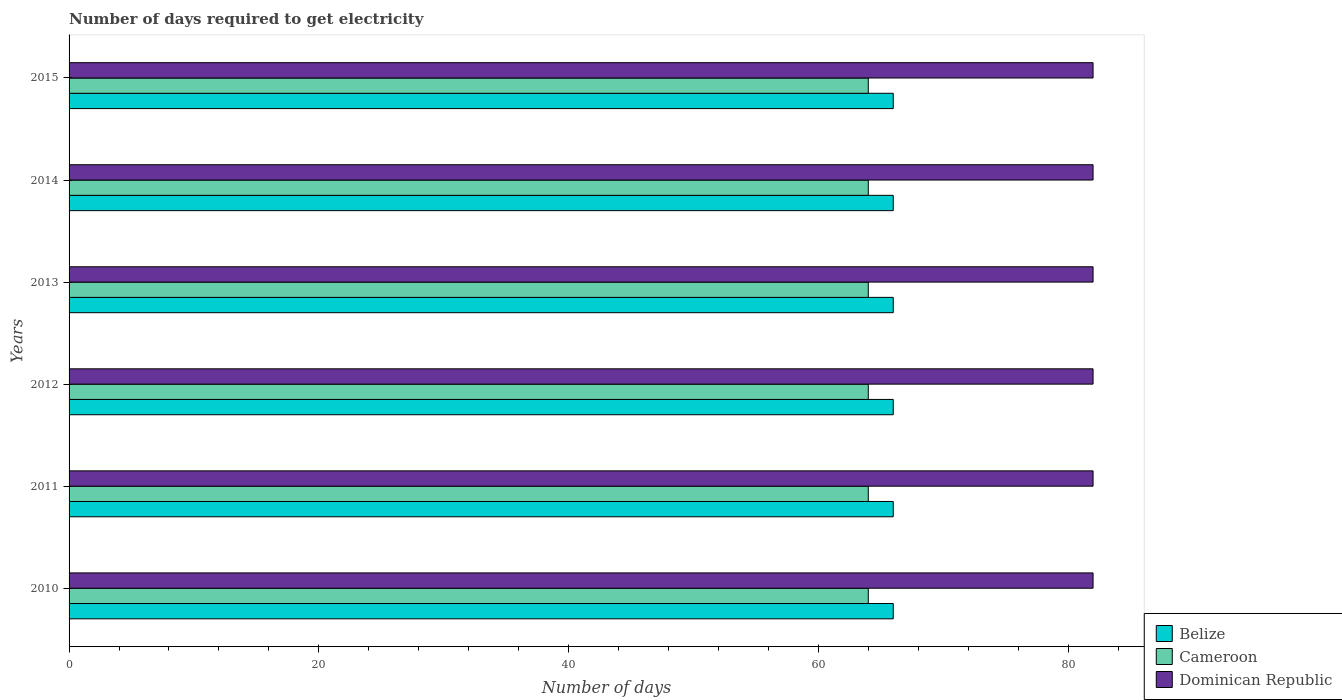How many groups of bars are there?
Make the answer very short. 6. Are the number of bars on each tick of the Y-axis equal?
Make the answer very short. Yes. How many bars are there on the 4th tick from the top?
Provide a short and direct response. 3. How many bars are there on the 3rd tick from the bottom?
Offer a terse response. 3. What is the label of the 2nd group of bars from the top?
Offer a very short reply. 2014. What is the number of days required to get electricity in in Cameroon in 2012?
Give a very brief answer. 64. Across all years, what is the maximum number of days required to get electricity in in Cameroon?
Offer a terse response. 64. Across all years, what is the minimum number of days required to get electricity in in Belize?
Make the answer very short. 66. In which year was the number of days required to get electricity in in Cameroon maximum?
Your answer should be very brief. 2010. What is the total number of days required to get electricity in in Cameroon in the graph?
Your answer should be very brief. 384. What is the difference between the number of days required to get electricity in in Cameroon in 2012 and that in 2013?
Ensure brevity in your answer.  0. What is the difference between the number of days required to get electricity in in Dominican Republic in 2011 and the number of days required to get electricity in in Cameroon in 2012?
Offer a terse response. 18. In the year 2013, what is the difference between the number of days required to get electricity in in Dominican Republic and number of days required to get electricity in in Cameroon?
Make the answer very short. 18. In how many years, is the number of days required to get electricity in in Dominican Republic greater than 64 days?
Offer a very short reply. 6. Is the number of days required to get electricity in in Dominican Republic in 2012 less than that in 2015?
Your answer should be very brief. No. What is the difference between the highest and the second highest number of days required to get electricity in in Cameroon?
Make the answer very short. 0. What is the difference between the highest and the lowest number of days required to get electricity in in Belize?
Keep it short and to the point. 0. In how many years, is the number of days required to get electricity in in Belize greater than the average number of days required to get electricity in in Belize taken over all years?
Keep it short and to the point. 0. What does the 3rd bar from the top in 2014 represents?
Make the answer very short. Belize. What does the 2nd bar from the bottom in 2014 represents?
Offer a very short reply. Cameroon. Are all the bars in the graph horizontal?
Your answer should be very brief. Yes. How many years are there in the graph?
Give a very brief answer. 6. What is the difference between two consecutive major ticks on the X-axis?
Keep it short and to the point. 20. How many legend labels are there?
Offer a very short reply. 3. How are the legend labels stacked?
Provide a short and direct response. Vertical. What is the title of the graph?
Make the answer very short. Number of days required to get electricity. What is the label or title of the X-axis?
Give a very brief answer. Number of days. What is the Number of days of Cameroon in 2010?
Your answer should be compact. 64. What is the Number of days of Dominican Republic in 2011?
Make the answer very short. 82. What is the Number of days in Cameroon in 2013?
Offer a terse response. 64. What is the Number of days in Cameroon in 2014?
Keep it short and to the point. 64. What is the Number of days in Cameroon in 2015?
Ensure brevity in your answer.  64. Across all years, what is the maximum Number of days of Belize?
Ensure brevity in your answer.  66. What is the total Number of days in Belize in the graph?
Give a very brief answer. 396. What is the total Number of days in Cameroon in the graph?
Offer a very short reply. 384. What is the total Number of days of Dominican Republic in the graph?
Provide a short and direct response. 492. What is the difference between the Number of days in Dominican Republic in 2010 and that in 2011?
Provide a succinct answer. 0. What is the difference between the Number of days of Cameroon in 2010 and that in 2014?
Provide a short and direct response. 0. What is the difference between the Number of days in Dominican Republic in 2010 and that in 2014?
Offer a very short reply. 0. What is the difference between the Number of days in Belize in 2010 and that in 2015?
Give a very brief answer. 0. What is the difference between the Number of days of Cameroon in 2010 and that in 2015?
Provide a short and direct response. 0. What is the difference between the Number of days in Dominican Republic in 2010 and that in 2015?
Make the answer very short. 0. What is the difference between the Number of days in Belize in 2011 and that in 2012?
Your response must be concise. 0. What is the difference between the Number of days of Dominican Republic in 2011 and that in 2012?
Your answer should be very brief. 0. What is the difference between the Number of days of Cameroon in 2011 and that in 2013?
Offer a terse response. 0. What is the difference between the Number of days of Dominican Republic in 2011 and that in 2013?
Provide a short and direct response. 0. What is the difference between the Number of days of Dominican Republic in 2011 and that in 2014?
Offer a very short reply. 0. What is the difference between the Number of days in Cameroon in 2011 and that in 2015?
Keep it short and to the point. 0. What is the difference between the Number of days of Belize in 2012 and that in 2013?
Make the answer very short. 0. What is the difference between the Number of days in Cameroon in 2012 and that in 2013?
Make the answer very short. 0. What is the difference between the Number of days of Belize in 2012 and that in 2014?
Offer a very short reply. 0. What is the difference between the Number of days of Cameroon in 2012 and that in 2014?
Your answer should be compact. 0. What is the difference between the Number of days of Dominican Republic in 2012 and that in 2014?
Your answer should be very brief. 0. What is the difference between the Number of days of Belize in 2013 and that in 2014?
Keep it short and to the point. 0. What is the difference between the Number of days of Cameroon in 2013 and that in 2014?
Your answer should be compact. 0. What is the difference between the Number of days of Cameroon in 2013 and that in 2015?
Your answer should be compact. 0. What is the difference between the Number of days of Dominican Republic in 2013 and that in 2015?
Ensure brevity in your answer.  0. What is the difference between the Number of days of Cameroon in 2014 and that in 2015?
Offer a terse response. 0. What is the difference between the Number of days in Belize in 2010 and the Number of days in Dominican Republic in 2011?
Provide a succinct answer. -16. What is the difference between the Number of days in Cameroon in 2010 and the Number of days in Dominican Republic in 2011?
Give a very brief answer. -18. What is the difference between the Number of days of Belize in 2010 and the Number of days of Cameroon in 2012?
Give a very brief answer. 2. What is the difference between the Number of days of Belize in 2010 and the Number of days of Cameroon in 2013?
Provide a short and direct response. 2. What is the difference between the Number of days of Belize in 2010 and the Number of days of Dominican Republic in 2013?
Provide a succinct answer. -16. What is the difference between the Number of days in Cameroon in 2010 and the Number of days in Dominican Republic in 2013?
Your response must be concise. -18. What is the difference between the Number of days in Belize in 2010 and the Number of days in Dominican Republic in 2014?
Give a very brief answer. -16. What is the difference between the Number of days of Belize in 2011 and the Number of days of Dominican Republic in 2012?
Offer a very short reply. -16. What is the difference between the Number of days of Belize in 2011 and the Number of days of Cameroon in 2013?
Ensure brevity in your answer.  2. What is the difference between the Number of days of Belize in 2011 and the Number of days of Dominican Republic in 2013?
Keep it short and to the point. -16. What is the difference between the Number of days in Belize in 2011 and the Number of days in Cameroon in 2014?
Provide a succinct answer. 2. What is the difference between the Number of days in Belize in 2011 and the Number of days in Dominican Republic in 2014?
Your answer should be compact. -16. What is the difference between the Number of days in Cameroon in 2011 and the Number of days in Dominican Republic in 2014?
Your response must be concise. -18. What is the difference between the Number of days in Belize in 2011 and the Number of days in Dominican Republic in 2015?
Provide a succinct answer. -16. What is the difference between the Number of days in Belize in 2012 and the Number of days in Cameroon in 2013?
Offer a terse response. 2. What is the difference between the Number of days of Belize in 2012 and the Number of days of Dominican Republic in 2013?
Provide a short and direct response. -16. What is the difference between the Number of days of Cameroon in 2012 and the Number of days of Dominican Republic in 2013?
Provide a short and direct response. -18. What is the difference between the Number of days of Belize in 2012 and the Number of days of Cameroon in 2014?
Provide a short and direct response. 2. What is the difference between the Number of days in Cameroon in 2013 and the Number of days in Dominican Republic in 2015?
Your answer should be very brief. -18. What is the difference between the Number of days of Belize in 2014 and the Number of days of Dominican Republic in 2015?
Ensure brevity in your answer.  -16. What is the difference between the Number of days in Cameroon in 2014 and the Number of days in Dominican Republic in 2015?
Your response must be concise. -18. What is the average Number of days in Belize per year?
Your response must be concise. 66. In the year 2010, what is the difference between the Number of days in Belize and Number of days in Cameroon?
Offer a very short reply. 2. In the year 2010, what is the difference between the Number of days of Cameroon and Number of days of Dominican Republic?
Your answer should be compact. -18. In the year 2011, what is the difference between the Number of days in Belize and Number of days in Dominican Republic?
Your answer should be compact. -16. In the year 2013, what is the difference between the Number of days of Belize and Number of days of Cameroon?
Your response must be concise. 2. In the year 2013, what is the difference between the Number of days in Belize and Number of days in Dominican Republic?
Provide a succinct answer. -16. In the year 2015, what is the difference between the Number of days of Belize and Number of days of Cameroon?
Your response must be concise. 2. What is the ratio of the Number of days in Cameroon in 2010 to that in 2011?
Your answer should be very brief. 1. What is the ratio of the Number of days of Dominican Republic in 2010 to that in 2011?
Your answer should be very brief. 1. What is the ratio of the Number of days in Cameroon in 2010 to that in 2012?
Keep it short and to the point. 1. What is the ratio of the Number of days of Dominican Republic in 2010 to that in 2012?
Provide a succinct answer. 1. What is the ratio of the Number of days of Cameroon in 2010 to that in 2013?
Your answer should be compact. 1. What is the ratio of the Number of days of Dominican Republic in 2010 to that in 2013?
Give a very brief answer. 1. What is the ratio of the Number of days in Cameroon in 2010 to that in 2014?
Provide a short and direct response. 1. What is the ratio of the Number of days in Belize in 2011 to that in 2012?
Offer a very short reply. 1. What is the ratio of the Number of days of Belize in 2011 to that in 2013?
Your response must be concise. 1. What is the ratio of the Number of days in Dominican Republic in 2011 to that in 2014?
Your response must be concise. 1. What is the ratio of the Number of days in Cameroon in 2011 to that in 2015?
Offer a terse response. 1. What is the ratio of the Number of days in Cameroon in 2012 to that in 2013?
Make the answer very short. 1. What is the ratio of the Number of days in Belize in 2012 to that in 2015?
Give a very brief answer. 1. What is the ratio of the Number of days of Dominican Republic in 2012 to that in 2015?
Your response must be concise. 1. What is the ratio of the Number of days of Dominican Republic in 2013 to that in 2014?
Offer a very short reply. 1. What is the ratio of the Number of days of Dominican Republic in 2013 to that in 2015?
Your response must be concise. 1. What is the ratio of the Number of days of Belize in 2014 to that in 2015?
Offer a very short reply. 1. What is the ratio of the Number of days in Cameroon in 2014 to that in 2015?
Offer a terse response. 1. What is the difference between the highest and the second highest Number of days in Cameroon?
Your answer should be compact. 0. What is the difference between the highest and the lowest Number of days of Dominican Republic?
Ensure brevity in your answer.  0. 